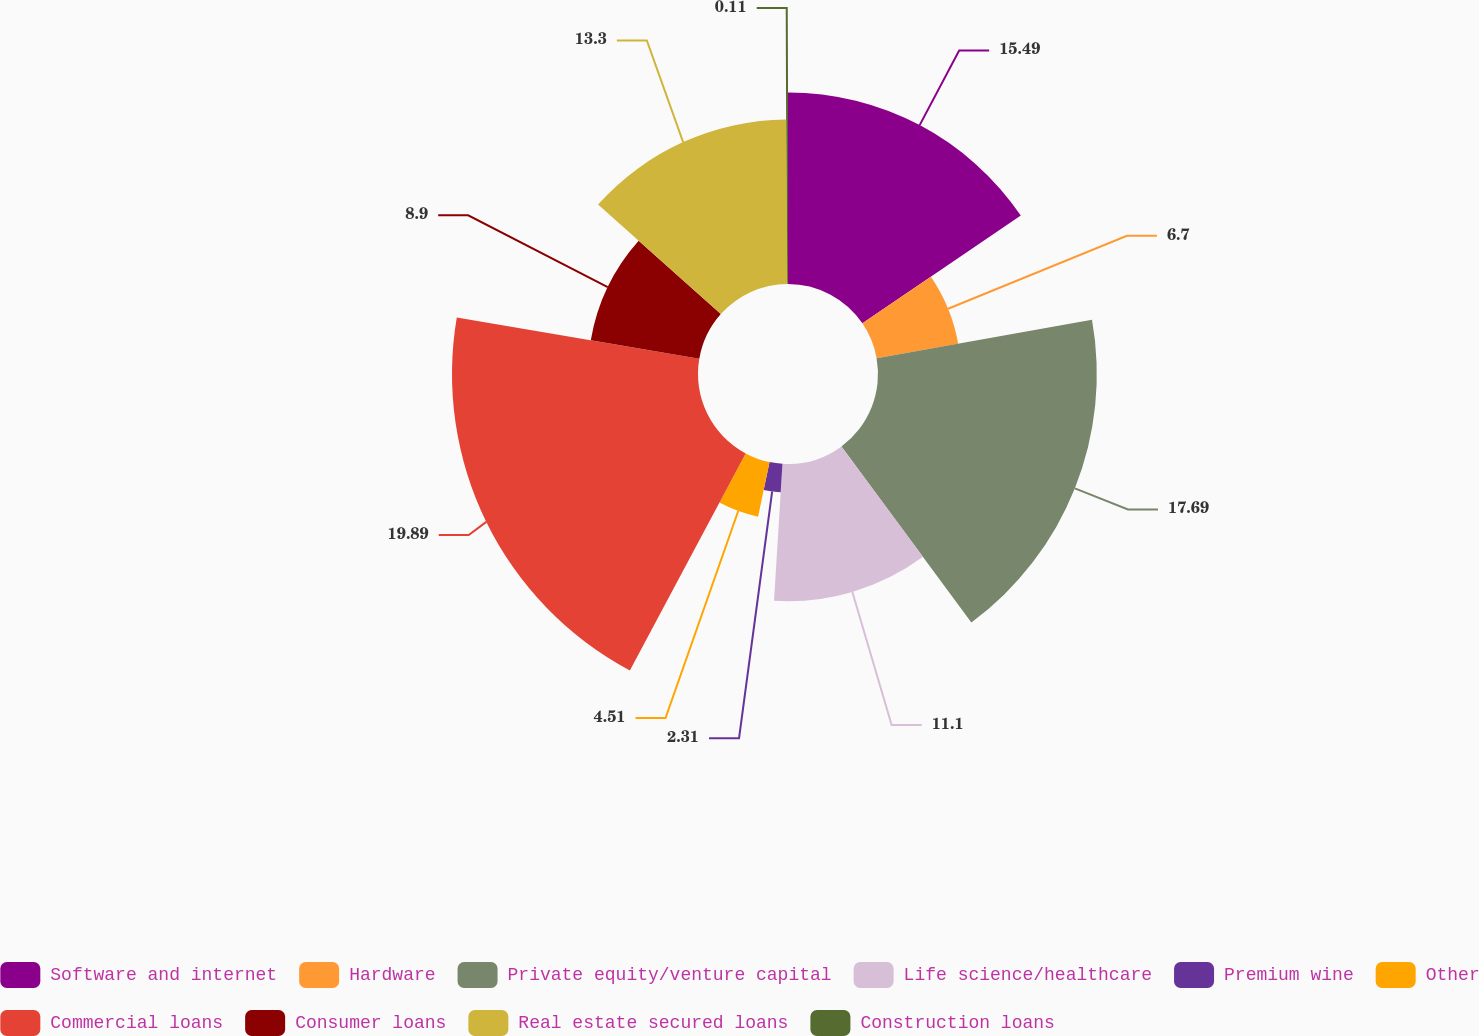Convert chart. <chart><loc_0><loc_0><loc_500><loc_500><pie_chart><fcel>Software and internet<fcel>Hardware<fcel>Private equity/venture capital<fcel>Life science/healthcare<fcel>Premium wine<fcel>Other<fcel>Commercial loans<fcel>Consumer loans<fcel>Real estate secured loans<fcel>Construction loans<nl><fcel>15.49%<fcel>6.7%<fcel>17.69%<fcel>11.1%<fcel>2.31%<fcel>4.51%<fcel>19.89%<fcel>8.9%<fcel>13.3%<fcel>0.11%<nl></chart> 